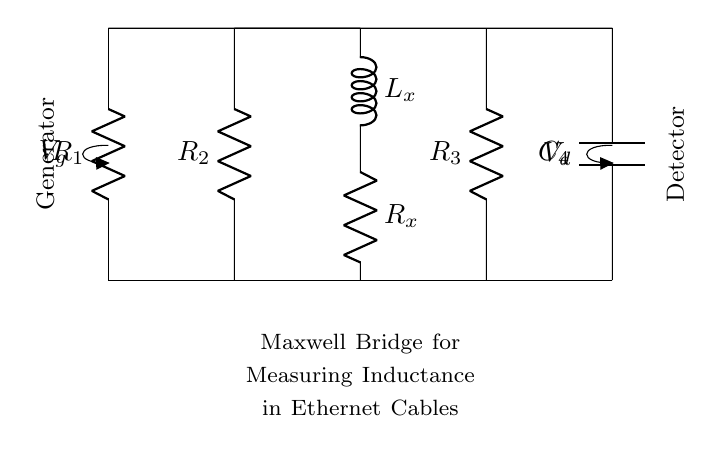What is the inductor value represented in this circuit? The inductor value is denoted by L_x in the schematic. Typically, this value is needed to determine the inductance in Ethernet cables during measurement.
Answer: L_x How many resistors are present in this Maxwell bridge circuit? The circuit diagram shows a total of three resistors labeled R_1, R_2, and R_3. These contribute to the measurement of inductance in the bridge configuration.
Answer: Three What type of component is connected across points V_g and V_d? The arrangement indicates that a capacitor labeled C_4 is connected at this position, which is essential for the operation of the bridge.
Answer: Capacitor How does the bridge balance condition relate the resistors and inductor? At balance, the ratio of resistances R_1 and R_2 equals the ratio of R_3 and the reactance of the inductor at the same frequency, allowing for precise inductance measurement.
Answer: Ratio equality What function does the voltage source V_g serve in this circuit? The voltage source V_g acts as the input signal for the Maxwell bridge, creating a potential difference necessary for the measurement process.
Answer: Input signal What is the main purpose of the Maxwell bridge in this configuration? The primary function of the Maxwell bridge is to accurately measure the inductance of components like those in Ethernet cables using the principles of balanced circuits.
Answer: Measure inductance 